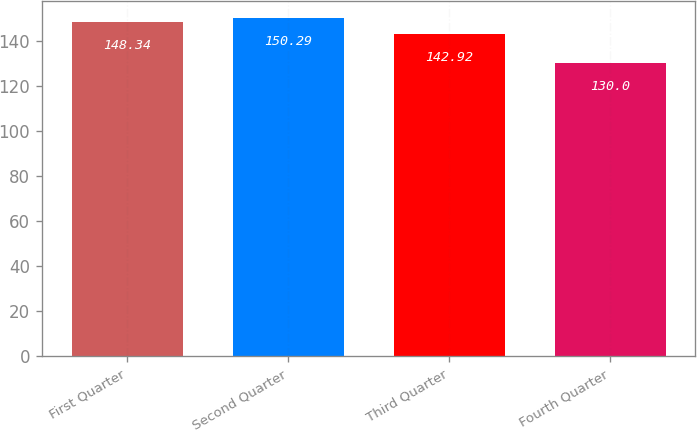Convert chart. <chart><loc_0><loc_0><loc_500><loc_500><bar_chart><fcel>First Quarter<fcel>Second Quarter<fcel>Third Quarter<fcel>Fourth Quarter<nl><fcel>148.34<fcel>150.29<fcel>142.92<fcel>130<nl></chart> 